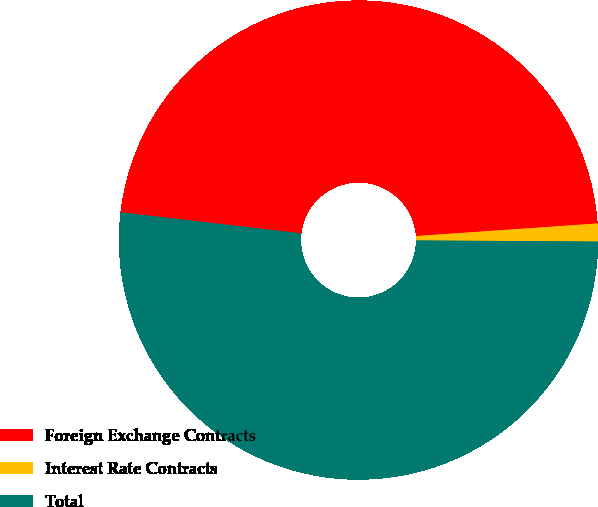Convert chart to OTSL. <chart><loc_0><loc_0><loc_500><loc_500><pie_chart><fcel>Foreign Exchange Contracts<fcel>Interest Rate Contracts<fcel>Total<nl><fcel>47.05%<fcel>1.2%<fcel>51.75%<nl></chart> 